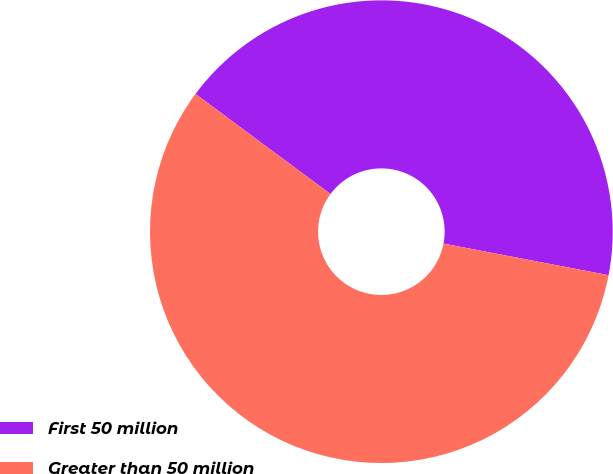Convert chart. <chart><loc_0><loc_0><loc_500><loc_500><pie_chart><fcel>First 50 million<fcel>Greater than 50 million<nl><fcel>42.86%<fcel>57.14%<nl></chart> 